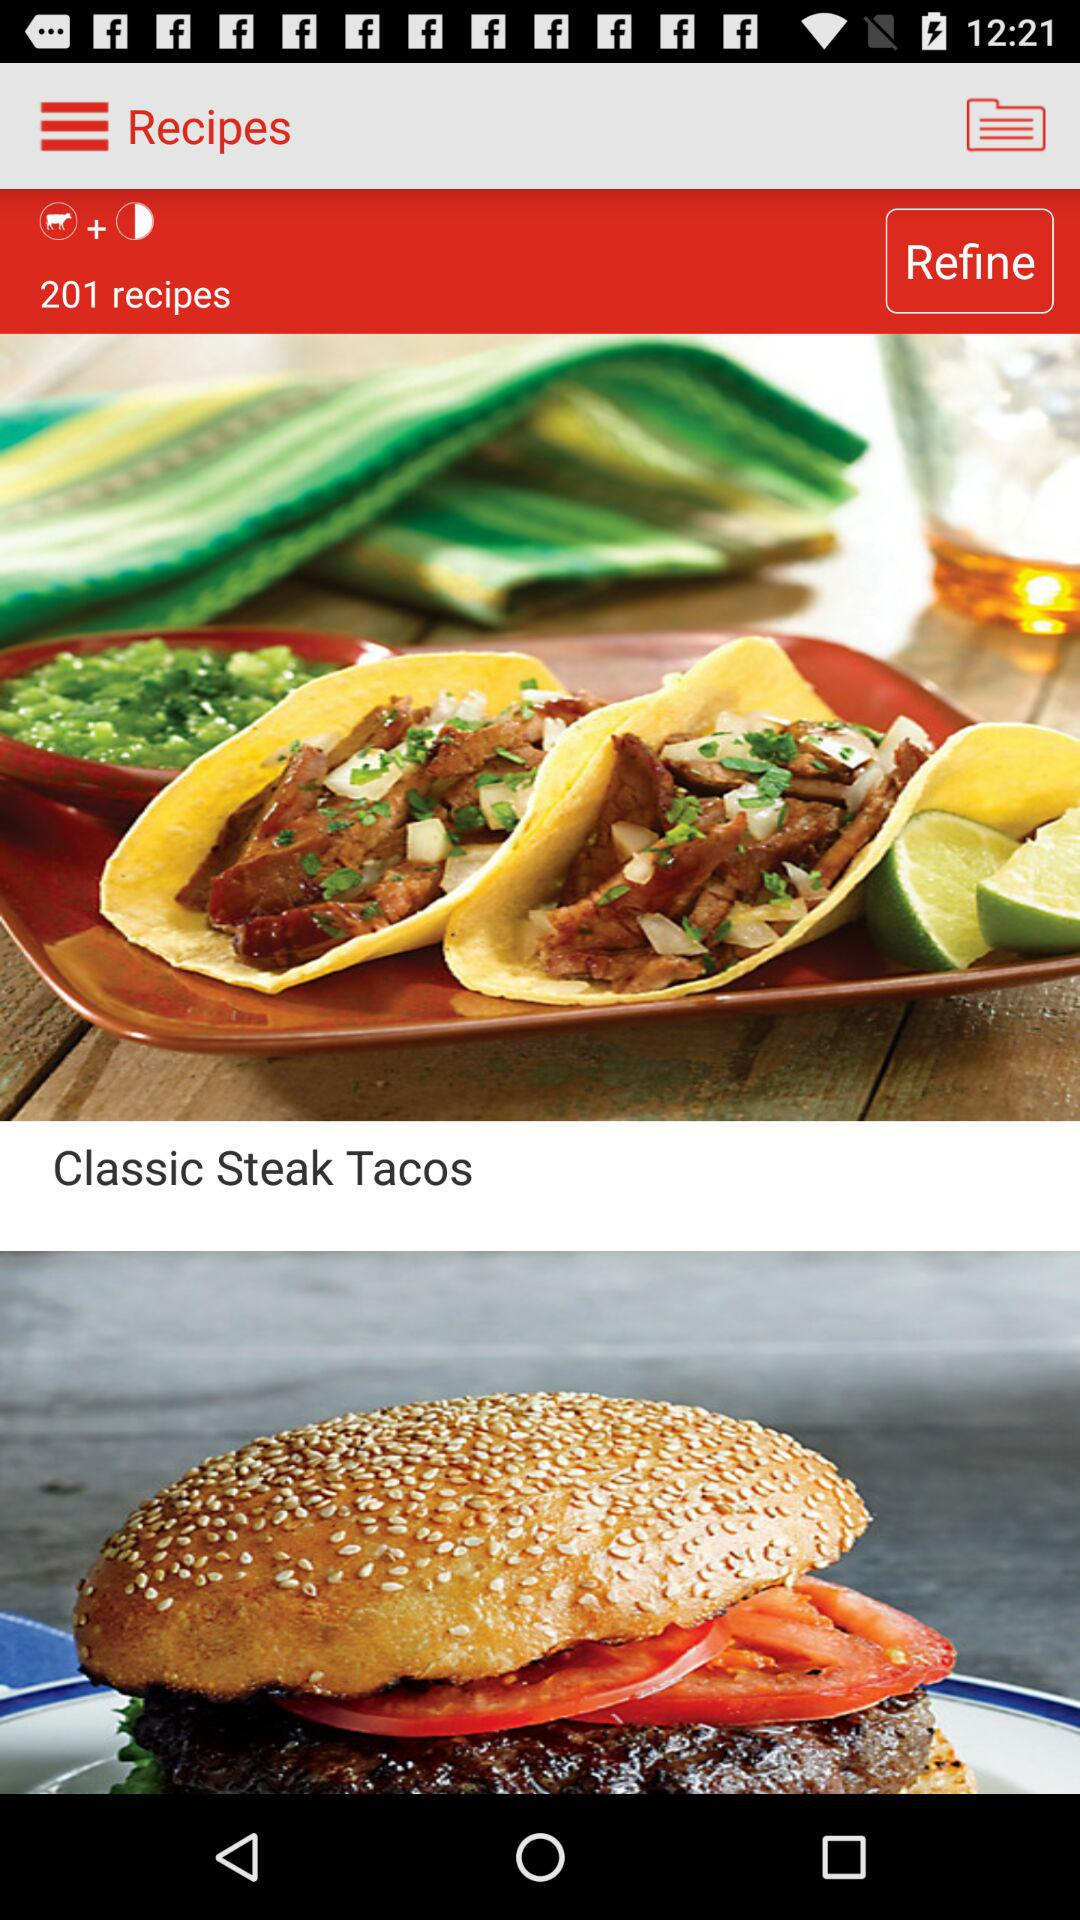How long does it take to make classic steak tacos?
When the provided information is insufficient, respond with <no answer>. <no answer> 